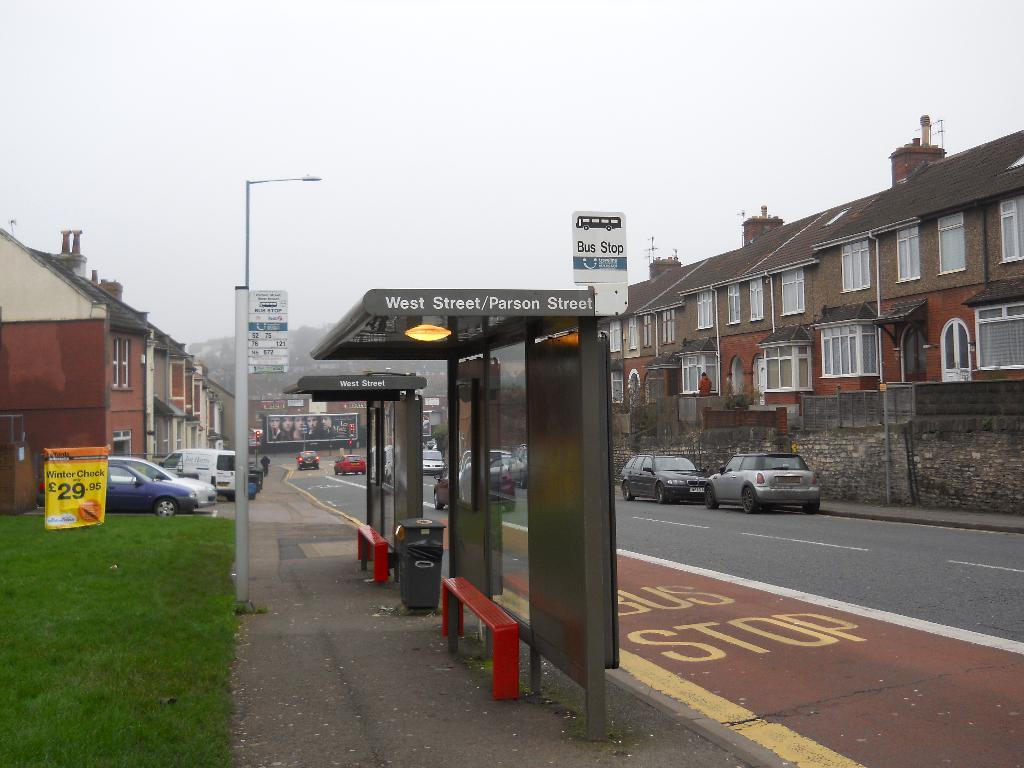<image>
Render a clear and concise summary of the photo. No one is waiting at the West Street / Parson Street bus stop. 